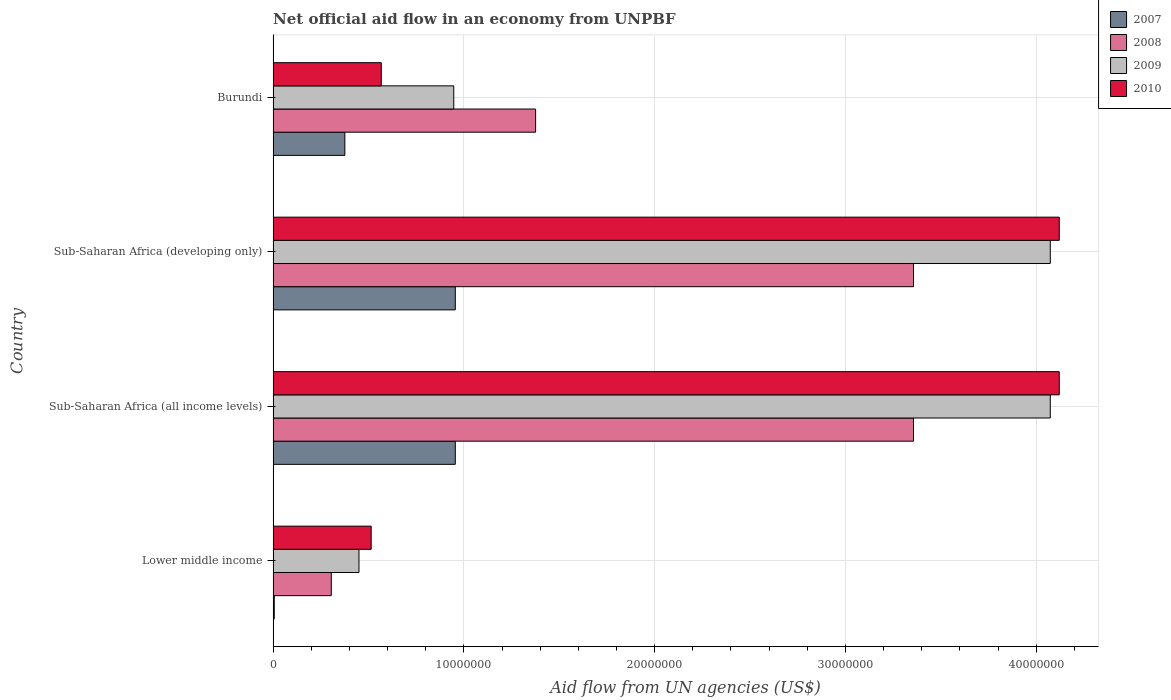How many different coloured bars are there?
Make the answer very short. 4. Are the number of bars on each tick of the Y-axis equal?
Provide a short and direct response. Yes. What is the label of the 1st group of bars from the top?
Give a very brief answer. Burundi. What is the net official aid flow in 2008 in Burundi?
Your answer should be compact. 1.38e+07. Across all countries, what is the maximum net official aid flow in 2007?
Give a very brief answer. 9.55e+06. Across all countries, what is the minimum net official aid flow in 2008?
Your answer should be compact. 3.05e+06. In which country was the net official aid flow in 2009 maximum?
Provide a short and direct response. Sub-Saharan Africa (all income levels). In which country was the net official aid flow in 2007 minimum?
Your answer should be compact. Lower middle income. What is the total net official aid flow in 2010 in the graph?
Ensure brevity in your answer.  9.32e+07. What is the difference between the net official aid flow in 2007 in Burundi and that in Sub-Saharan Africa (all income levels)?
Ensure brevity in your answer.  -5.79e+06. What is the difference between the net official aid flow in 2007 in Sub-Saharan Africa (developing only) and the net official aid flow in 2009 in Lower middle income?
Make the answer very short. 5.05e+06. What is the average net official aid flow in 2009 per country?
Make the answer very short. 2.39e+07. What is the ratio of the net official aid flow in 2010 in Burundi to that in Sub-Saharan Africa (all income levels)?
Ensure brevity in your answer.  0.14. Is the difference between the net official aid flow in 2010 in Sub-Saharan Africa (all income levels) and Sub-Saharan Africa (developing only) greater than the difference between the net official aid flow in 2009 in Sub-Saharan Africa (all income levels) and Sub-Saharan Africa (developing only)?
Offer a very short reply. No. What is the difference between the highest and the lowest net official aid flow in 2008?
Ensure brevity in your answer.  3.05e+07. What does the 1st bar from the top in Lower middle income represents?
Provide a short and direct response. 2010. Is it the case that in every country, the sum of the net official aid flow in 2007 and net official aid flow in 2008 is greater than the net official aid flow in 2010?
Make the answer very short. No. Are all the bars in the graph horizontal?
Provide a short and direct response. Yes. How many countries are there in the graph?
Make the answer very short. 4. What is the difference between two consecutive major ticks on the X-axis?
Your answer should be very brief. 1.00e+07. Does the graph contain any zero values?
Offer a very short reply. No. Does the graph contain grids?
Offer a very short reply. Yes. What is the title of the graph?
Provide a short and direct response. Net official aid flow in an economy from UNPBF. Does "1973" appear as one of the legend labels in the graph?
Your response must be concise. No. What is the label or title of the X-axis?
Your answer should be very brief. Aid flow from UN agencies (US$). What is the label or title of the Y-axis?
Give a very brief answer. Country. What is the Aid flow from UN agencies (US$) in 2008 in Lower middle income?
Make the answer very short. 3.05e+06. What is the Aid flow from UN agencies (US$) of 2009 in Lower middle income?
Your response must be concise. 4.50e+06. What is the Aid flow from UN agencies (US$) of 2010 in Lower middle income?
Offer a terse response. 5.14e+06. What is the Aid flow from UN agencies (US$) of 2007 in Sub-Saharan Africa (all income levels)?
Give a very brief answer. 9.55e+06. What is the Aid flow from UN agencies (US$) in 2008 in Sub-Saharan Africa (all income levels)?
Your response must be concise. 3.36e+07. What is the Aid flow from UN agencies (US$) in 2009 in Sub-Saharan Africa (all income levels)?
Make the answer very short. 4.07e+07. What is the Aid flow from UN agencies (US$) of 2010 in Sub-Saharan Africa (all income levels)?
Ensure brevity in your answer.  4.12e+07. What is the Aid flow from UN agencies (US$) in 2007 in Sub-Saharan Africa (developing only)?
Offer a very short reply. 9.55e+06. What is the Aid flow from UN agencies (US$) in 2008 in Sub-Saharan Africa (developing only)?
Give a very brief answer. 3.36e+07. What is the Aid flow from UN agencies (US$) of 2009 in Sub-Saharan Africa (developing only)?
Offer a very short reply. 4.07e+07. What is the Aid flow from UN agencies (US$) in 2010 in Sub-Saharan Africa (developing only)?
Offer a terse response. 4.12e+07. What is the Aid flow from UN agencies (US$) of 2007 in Burundi?
Give a very brief answer. 3.76e+06. What is the Aid flow from UN agencies (US$) in 2008 in Burundi?
Ensure brevity in your answer.  1.38e+07. What is the Aid flow from UN agencies (US$) of 2009 in Burundi?
Ensure brevity in your answer.  9.47e+06. What is the Aid flow from UN agencies (US$) in 2010 in Burundi?
Your answer should be very brief. 5.67e+06. Across all countries, what is the maximum Aid flow from UN agencies (US$) in 2007?
Your response must be concise. 9.55e+06. Across all countries, what is the maximum Aid flow from UN agencies (US$) in 2008?
Your answer should be compact. 3.36e+07. Across all countries, what is the maximum Aid flow from UN agencies (US$) in 2009?
Offer a very short reply. 4.07e+07. Across all countries, what is the maximum Aid flow from UN agencies (US$) of 2010?
Your answer should be very brief. 4.12e+07. Across all countries, what is the minimum Aid flow from UN agencies (US$) of 2007?
Ensure brevity in your answer.  6.00e+04. Across all countries, what is the minimum Aid flow from UN agencies (US$) of 2008?
Your answer should be very brief. 3.05e+06. Across all countries, what is the minimum Aid flow from UN agencies (US$) in 2009?
Offer a terse response. 4.50e+06. Across all countries, what is the minimum Aid flow from UN agencies (US$) of 2010?
Provide a short and direct response. 5.14e+06. What is the total Aid flow from UN agencies (US$) of 2007 in the graph?
Your answer should be compact. 2.29e+07. What is the total Aid flow from UN agencies (US$) in 2008 in the graph?
Your response must be concise. 8.40e+07. What is the total Aid flow from UN agencies (US$) in 2009 in the graph?
Provide a short and direct response. 9.54e+07. What is the total Aid flow from UN agencies (US$) in 2010 in the graph?
Make the answer very short. 9.32e+07. What is the difference between the Aid flow from UN agencies (US$) in 2007 in Lower middle income and that in Sub-Saharan Africa (all income levels)?
Your answer should be very brief. -9.49e+06. What is the difference between the Aid flow from UN agencies (US$) of 2008 in Lower middle income and that in Sub-Saharan Africa (all income levels)?
Make the answer very short. -3.05e+07. What is the difference between the Aid flow from UN agencies (US$) in 2009 in Lower middle income and that in Sub-Saharan Africa (all income levels)?
Your answer should be very brief. -3.62e+07. What is the difference between the Aid flow from UN agencies (US$) in 2010 in Lower middle income and that in Sub-Saharan Africa (all income levels)?
Keep it short and to the point. -3.61e+07. What is the difference between the Aid flow from UN agencies (US$) in 2007 in Lower middle income and that in Sub-Saharan Africa (developing only)?
Offer a very short reply. -9.49e+06. What is the difference between the Aid flow from UN agencies (US$) in 2008 in Lower middle income and that in Sub-Saharan Africa (developing only)?
Provide a succinct answer. -3.05e+07. What is the difference between the Aid flow from UN agencies (US$) in 2009 in Lower middle income and that in Sub-Saharan Africa (developing only)?
Ensure brevity in your answer.  -3.62e+07. What is the difference between the Aid flow from UN agencies (US$) of 2010 in Lower middle income and that in Sub-Saharan Africa (developing only)?
Keep it short and to the point. -3.61e+07. What is the difference between the Aid flow from UN agencies (US$) of 2007 in Lower middle income and that in Burundi?
Offer a terse response. -3.70e+06. What is the difference between the Aid flow from UN agencies (US$) in 2008 in Lower middle income and that in Burundi?
Ensure brevity in your answer.  -1.07e+07. What is the difference between the Aid flow from UN agencies (US$) in 2009 in Lower middle income and that in Burundi?
Provide a short and direct response. -4.97e+06. What is the difference between the Aid flow from UN agencies (US$) of 2010 in Lower middle income and that in Burundi?
Make the answer very short. -5.30e+05. What is the difference between the Aid flow from UN agencies (US$) in 2007 in Sub-Saharan Africa (all income levels) and that in Sub-Saharan Africa (developing only)?
Provide a short and direct response. 0. What is the difference between the Aid flow from UN agencies (US$) of 2007 in Sub-Saharan Africa (all income levels) and that in Burundi?
Offer a terse response. 5.79e+06. What is the difference between the Aid flow from UN agencies (US$) in 2008 in Sub-Saharan Africa (all income levels) and that in Burundi?
Your answer should be very brief. 1.98e+07. What is the difference between the Aid flow from UN agencies (US$) of 2009 in Sub-Saharan Africa (all income levels) and that in Burundi?
Your response must be concise. 3.13e+07. What is the difference between the Aid flow from UN agencies (US$) of 2010 in Sub-Saharan Africa (all income levels) and that in Burundi?
Offer a terse response. 3.55e+07. What is the difference between the Aid flow from UN agencies (US$) of 2007 in Sub-Saharan Africa (developing only) and that in Burundi?
Make the answer very short. 5.79e+06. What is the difference between the Aid flow from UN agencies (US$) of 2008 in Sub-Saharan Africa (developing only) and that in Burundi?
Offer a terse response. 1.98e+07. What is the difference between the Aid flow from UN agencies (US$) in 2009 in Sub-Saharan Africa (developing only) and that in Burundi?
Your response must be concise. 3.13e+07. What is the difference between the Aid flow from UN agencies (US$) in 2010 in Sub-Saharan Africa (developing only) and that in Burundi?
Your answer should be compact. 3.55e+07. What is the difference between the Aid flow from UN agencies (US$) in 2007 in Lower middle income and the Aid flow from UN agencies (US$) in 2008 in Sub-Saharan Africa (all income levels)?
Your answer should be compact. -3.35e+07. What is the difference between the Aid flow from UN agencies (US$) in 2007 in Lower middle income and the Aid flow from UN agencies (US$) in 2009 in Sub-Saharan Africa (all income levels)?
Make the answer very short. -4.07e+07. What is the difference between the Aid flow from UN agencies (US$) of 2007 in Lower middle income and the Aid flow from UN agencies (US$) of 2010 in Sub-Saharan Africa (all income levels)?
Your answer should be compact. -4.12e+07. What is the difference between the Aid flow from UN agencies (US$) of 2008 in Lower middle income and the Aid flow from UN agencies (US$) of 2009 in Sub-Saharan Africa (all income levels)?
Offer a very short reply. -3.77e+07. What is the difference between the Aid flow from UN agencies (US$) in 2008 in Lower middle income and the Aid flow from UN agencies (US$) in 2010 in Sub-Saharan Africa (all income levels)?
Give a very brief answer. -3.82e+07. What is the difference between the Aid flow from UN agencies (US$) in 2009 in Lower middle income and the Aid flow from UN agencies (US$) in 2010 in Sub-Saharan Africa (all income levels)?
Provide a short and direct response. -3.67e+07. What is the difference between the Aid flow from UN agencies (US$) of 2007 in Lower middle income and the Aid flow from UN agencies (US$) of 2008 in Sub-Saharan Africa (developing only)?
Make the answer very short. -3.35e+07. What is the difference between the Aid flow from UN agencies (US$) in 2007 in Lower middle income and the Aid flow from UN agencies (US$) in 2009 in Sub-Saharan Africa (developing only)?
Provide a short and direct response. -4.07e+07. What is the difference between the Aid flow from UN agencies (US$) in 2007 in Lower middle income and the Aid flow from UN agencies (US$) in 2010 in Sub-Saharan Africa (developing only)?
Keep it short and to the point. -4.12e+07. What is the difference between the Aid flow from UN agencies (US$) of 2008 in Lower middle income and the Aid flow from UN agencies (US$) of 2009 in Sub-Saharan Africa (developing only)?
Your answer should be compact. -3.77e+07. What is the difference between the Aid flow from UN agencies (US$) of 2008 in Lower middle income and the Aid flow from UN agencies (US$) of 2010 in Sub-Saharan Africa (developing only)?
Ensure brevity in your answer.  -3.82e+07. What is the difference between the Aid flow from UN agencies (US$) of 2009 in Lower middle income and the Aid flow from UN agencies (US$) of 2010 in Sub-Saharan Africa (developing only)?
Provide a short and direct response. -3.67e+07. What is the difference between the Aid flow from UN agencies (US$) of 2007 in Lower middle income and the Aid flow from UN agencies (US$) of 2008 in Burundi?
Your answer should be very brief. -1.37e+07. What is the difference between the Aid flow from UN agencies (US$) of 2007 in Lower middle income and the Aid flow from UN agencies (US$) of 2009 in Burundi?
Your response must be concise. -9.41e+06. What is the difference between the Aid flow from UN agencies (US$) of 2007 in Lower middle income and the Aid flow from UN agencies (US$) of 2010 in Burundi?
Keep it short and to the point. -5.61e+06. What is the difference between the Aid flow from UN agencies (US$) of 2008 in Lower middle income and the Aid flow from UN agencies (US$) of 2009 in Burundi?
Your answer should be compact. -6.42e+06. What is the difference between the Aid flow from UN agencies (US$) in 2008 in Lower middle income and the Aid flow from UN agencies (US$) in 2010 in Burundi?
Provide a short and direct response. -2.62e+06. What is the difference between the Aid flow from UN agencies (US$) in 2009 in Lower middle income and the Aid flow from UN agencies (US$) in 2010 in Burundi?
Ensure brevity in your answer.  -1.17e+06. What is the difference between the Aid flow from UN agencies (US$) in 2007 in Sub-Saharan Africa (all income levels) and the Aid flow from UN agencies (US$) in 2008 in Sub-Saharan Africa (developing only)?
Your answer should be very brief. -2.40e+07. What is the difference between the Aid flow from UN agencies (US$) of 2007 in Sub-Saharan Africa (all income levels) and the Aid flow from UN agencies (US$) of 2009 in Sub-Saharan Africa (developing only)?
Your answer should be compact. -3.12e+07. What is the difference between the Aid flow from UN agencies (US$) in 2007 in Sub-Saharan Africa (all income levels) and the Aid flow from UN agencies (US$) in 2010 in Sub-Saharan Africa (developing only)?
Your answer should be compact. -3.17e+07. What is the difference between the Aid flow from UN agencies (US$) of 2008 in Sub-Saharan Africa (all income levels) and the Aid flow from UN agencies (US$) of 2009 in Sub-Saharan Africa (developing only)?
Your answer should be very brief. -7.17e+06. What is the difference between the Aid flow from UN agencies (US$) in 2008 in Sub-Saharan Africa (all income levels) and the Aid flow from UN agencies (US$) in 2010 in Sub-Saharan Africa (developing only)?
Provide a short and direct response. -7.64e+06. What is the difference between the Aid flow from UN agencies (US$) in 2009 in Sub-Saharan Africa (all income levels) and the Aid flow from UN agencies (US$) in 2010 in Sub-Saharan Africa (developing only)?
Offer a very short reply. -4.70e+05. What is the difference between the Aid flow from UN agencies (US$) of 2007 in Sub-Saharan Africa (all income levels) and the Aid flow from UN agencies (US$) of 2008 in Burundi?
Provide a short and direct response. -4.21e+06. What is the difference between the Aid flow from UN agencies (US$) in 2007 in Sub-Saharan Africa (all income levels) and the Aid flow from UN agencies (US$) in 2009 in Burundi?
Your response must be concise. 8.00e+04. What is the difference between the Aid flow from UN agencies (US$) in 2007 in Sub-Saharan Africa (all income levels) and the Aid flow from UN agencies (US$) in 2010 in Burundi?
Keep it short and to the point. 3.88e+06. What is the difference between the Aid flow from UN agencies (US$) in 2008 in Sub-Saharan Africa (all income levels) and the Aid flow from UN agencies (US$) in 2009 in Burundi?
Provide a short and direct response. 2.41e+07. What is the difference between the Aid flow from UN agencies (US$) of 2008 in Sub-Saharan Africa (all income levels) and the Aid flow from UN agencies (US$) of 2010 in Burundi?
Provide a succinct answer. 2.79e+07. What is the difference between the Aid flow from UN agencies (US$) of 2009 in Sub-Saharan Africa (all income levels) and the Aid flow from UN agencies (US$) of 2010 in Burundi?
Give a very brief answer. 3.51e+07. What is the difference between the Aid flow from UN agencies (US$) in 2007 in Sub-Saharan Africa (developing only) and the Aid flow from UN agencies (US$) in 2008 in Burundi?
Provide a succinct answer. -4.21e+06. What is the difference between the Aid flow from UN agencies (US$) of 2007 in Sub-Saharan Africa (developing only) and the Aid flow from UN agencies (US$) of 2010 in Burundi?
Keep it short and to the point. 3.88e+06. What is the difference between the Aid flow from UN agencies (US$) of 2008 in Sub-Saharan Africa (developing only) and the Aid flow from UN agencies (US$) of 2009 in Burundi?
Make the answer very short. 2.41e+07. What is the difference between the Aid flow from UN agencies (US$) in 2008 in Sub-Saharan Africa (developing only) and the Aid flow from UN agencies (US$) in 2010 in Burundi?
Give a very brief answer. 2.79e+07. What is the difference between the Aid flow from UN agencies (US$) of 2009 in Sub-Saharan Africa (developing only) and the Aid flow from UN agencies (US$) of 2010 in Burundi?
Your response must be concise. 3.51e+07. What is the average Aid flow from UN agencies (US$) in 2007 per country?
Provide a short and direct response. 5.73e+06. What is the average Aid flow from UN agencies (US$) in 2008 per country?
Provide a short and direct response. 2.10e+07. What is the average Aid flow from UN agencies (US$) of 2009 per country?
Give a very brief answer. 2.39e+07. What is the average Aid flow from UN agencies (US$) in 2010 per country?
Keep it short and to the point. 2.33e+07. What is the difference between the Aid flow from UN agencies (US$) of 2007 and Aid flow from UN agencies (US$) of 2008 in Lower middle income?
Offer a terse response. -2.99e+06. What is the difference between the Aid flow from UN agencies (US$) of 2007 and Aid flow from UN agencies (US$) of 2009 in Lower middle income?
Give a very brief answer. -4.44e+06. What is the difference between the Aid flow from UN agencies (US$) of 2007 and Aid flow from UN agencies (US$) of 2010 in Lower middle income?
Make the answer very short. -5.08e+06. What is the difference between the Aid flow from UN agencies (US$) in 2008 and Aid flow from UN agencies (US$) in 2009 in Lower middle income?
Keep it short and to the point. -1.45e+06. What is the difference between the Aid flow from UN agencies (US$) in 2008 and Aid flow from UN agencies (US$) in 2010 in Lower middle income?
Your answer should be very brief. -2.09e+06. What is the difference between the Aid flow from UN agencies (US$) in 2009 and Aid flow from UN agencies (US$) in 2010 in Lower middle income?
Ensure brevity in your answer.  -6.40e+05. What is the difference between the Aid flow from UN agencies (US$) in 2007 and Aid flow from UN agencies (US$) in 2008 in Sub-Saharan Africa (all income levels)?
Your answer should be compact. -2.40e+07. What is the difference between the Aid flow from UN agencies (US$) in 2007 and Aid flow from UN agencies (US$) in 2009 in Sub-Saharan Africa (all income levels)?
Give a very brief answer. -3.12e+07. What is the difference between the Aid flow from UN agencies (US$) in 2007 and Aid flow from UN agencies (US$) in 2010 in Sub-Saharan Africa (all income levels)?
Provide a short and direct response. -3.17e+07. What is the difference between the Aid flow from UN agencies (US$) in 2008 and Aid flow from UN agencies (US$) in 2009 in Sub-Saharan Africa (all income levels)?
Keep it short and to the point. -7.17e+06. What is the difference between the Aid flow from UN agencies (US$) in 2008 and Aid flow from UN agencies (US$) in 2010 in Sub-Saharan Africa (all income levels)?
Ensure brevity in your answer.  -7.64e+06. What is the difference between the Aid flow from UN agencies (US$) in 2009 and Aid flow from UN agencies (US$) in 2010 in Sub-Saharan Africa (all income levels)?
Your response must be concise. -4.70e+05. What is the difference between the Aid flow from UN agencies (US$) in 2007 and Aid flow from UN agencies (US$) in 2008 in Sub-Saharan Africa (developing only)?
Offer a very short reply. -2.40e+07. What is the difference between the Aid flow from UN agencies (US$) in 2007 and Aid flow from UN agencies (US$) in 2009 in Sub-Saharan Africa (developing only)?
Ensure brevity in your answer.  -3.12e+07. What is the difference between the Aid flow from UN agencies (US$) of 2007 and Aid flow from UN agencies (US$) of 2010 in Sub-Saharan Africa (developing only)?
Provide a short and direct response. -3.17e+07. What is the difference between the Aid flow from UN agencies (US$) of 2008 and Aid flow from UN agencies (US$) of 2009 in Sub-Saharan Africa (developing only)?
Your answer should be very brief. -7.17e+06. What is the difference between the Aid flow from UN agencies (US$) in 2008 and Aid flow from UN agencies (US$) in 2010 in Sub-Saharan Africa (developing only)?
Keep it short and to the point. -7.64e+06. What is the difference between the Aid flow from UN agencies (US$) in 2009 and Aid flow from UN agencies (US$) in 2010 in Sub-Saharan Africa (developing only)?
Offer a very short reply. -4.70e+05. What is the difference between the Aid flow from UN agencies (US$) in 2007 and Aid flow from UN agencies (US$) in 2008 in Burundi?
Offer a very short reply. -1.00e+07. What is the difference between the Aid flow from UN agencies (US$) of 2007 and Aid flow from UN agencies (US$) of 2009 in Burundi?
Your answer should be compact. -5.71e+06. What is the difference between the Aid flow from UN agencies (US$) in 2007 and Aid flow from UN agencies (US$) in 2010 in Burundi?
Provide a succinct answer. -1.91e+06. What is the difference between the Aid flow from UN agencies (US$) of 2008 and Aid flow from UN agencies (US$) of 2009 in Burundi?
Your response must be concise. 4.29e+06. What is the difference between the Aid flow from UN agencies (US$) of 2008 and Aid flow from UN agencies (US$) of 2010 in Burundi?
Your answer should be very brief. 8.09e+06. What is the difference between the Aid flow from UN agencies (US$) in 2009 and Aid flow from UN agencies (US$) in 2010 in Burundi?
Keep it short and to the point. 3.80e+06. What is the ratio of the Aid flow from UN agencies (US$) in 2007 in Lower middle income to that in Sub-Saharan Africa (all income levels)?
Provide a short and direct response. 0.01. What is the ratio of the Aid flow from UN agencies (US$) in 2008 in Lower middle income to that in Sub-Saharan Africa (all income levels)?
Ensure brevity in your answer.  0.09. What is the ratio of the Aid flow from UN agencies (US$) in 2009 in Lower middle income to that in Sub-Saharan Africa (all income levels)?
Ensure brevity in your answer.  0.11. What is the ratio of the Aid flow from UN agencies (US$) of 2010 in Lower middle income to that in Sub-Saharan Africa (all income levels)?
Provide a succinct answer. 0.12. What is the ratio of the Aid flow from UN agencies (US$) of 2007 in Lower middle income to that in Sub-Saharan Africa (developing only)?
Your answer should be very brief. 0.01. What is the ratio of the Aid flow from UN agencies (US$) of 2008 in Lower middle income to that in Sub-Saharan Africa (developing only)?
Provide a succinct answer. 0.09. What is the ratio of the Aid flow from UN agencies (US$) of 2009 in Lower middle income to that in Sub-Saharan Africa (developing only)?
Your answer should be compact. 0.11. What is the ratio of the Aid flow from UN agencies (US$) of 2010 in Lower middle income to that in Sub-Saharan Africa (developing only)?
Offer a very short reply. 0.12. What is the ratio of the Aid flow from UN agencies (US$) of 2007 in Lower middle income to that in Burundi?
Ensure brevity in your answer.  0.02. What is the ratio of the Aid flow from UN agencies (US$) of 2008 in Lower middle income to that in Burundi?
Your answer should be compact. 0.22. What is the ratio of the Aid flow from UN agencies (US$) in 2009 in Lower middle income to that in Burundi?
Ensure brevity in your answer.  0.48. What is the ratio of the Aid flow from UN agencies (US$) in 2010 in Lower middle income to that in Burundi?
Ensure brevity in your answer.  0.91. What is the ratio of the Aid flow from UN agencies (US$) of 2008 in Sub-Saharan Africa (all income levels) to that in Sub-Saharan Africa (developing only)?
Provide a short and direct response. 1. What is the ratio of the Aid flow from UN agencies (US$) in 2009 in Sub-Saharan Africa (all income levels) to that in Sub-Saharan Africa (developing only)?
Offer a terse response. 1. What is the ratio of the Aid flow from UN agencies (US$) of 2010 in Sub-Saharan Africa (all income levels) to that in Sub-Saharan Africa (developing only)?
Provide a succinct answer. 1. What is the ratio of the Aid flow from UN agencies (US$) of 2007 in Sub-Saharan Africa (all income levels) to that in Burundi?
Give a very brief answer. 2.54. What is the ratio of the Aid flow from UN agencies (US$) in 2008 in Sub-Saharan Africa (all income levels) to that in Burundi?
Make the answer very short. 2.44. What is the ratio of the Aid flow from UN agencies (US$) in 2009 in Sub-Saharan Africa (all income levels) to that in Burundi?
Offer a very short reply. 4.3. What is the ratio of the Aid flow from UN agencies (US$) of 2010 in Sub-Saharan Africa (all income levels) to that in Burundi?
Your response must be concise. 7.27. What is the ratio of the Aid flow from UN agencies (US$) in 2007 in Sub-Saharan Africa (developing only) to that in Burundi?
Your response must be concise. 2.54. What is the ratio of the Aid flow from UN agencies (US$) of 2008 in Sub-Saharan Africa (developing only) to that in Burundi?
Your response must be concise. 2.44. What is the ratio of the Aid flow from UN agencies (US$) of 2009 in Sub-Saharan Africa (developing only) to that in Burundi?
Keep it short and to the point. 4.3. What is the ratio of the Aid flow from UN agencies (US$) of 2010 in Sub-Saharan Africa (developing only) to that in Burundi?
Provide a short and direct response. 7.27. What is the difference between the highest and the lowest Aid flow from UN agencies (US$) of 2007?
Offer a very short reply. 9.49e+06. What is the difference between the highest and the lowest Aid flow from UN agencies (US$) in 2008?
Make the answer very short. 3.05e+07. What is the difference between the highest and the lowest Aid flow from UN agencies (US$) in 2009?
Offer a terse response. 3.62e+07. What is the difference between the highest and the lowest Aid flow from UN agencies (US$) of 2010?
Offer a terse response. 3.61e+07. 